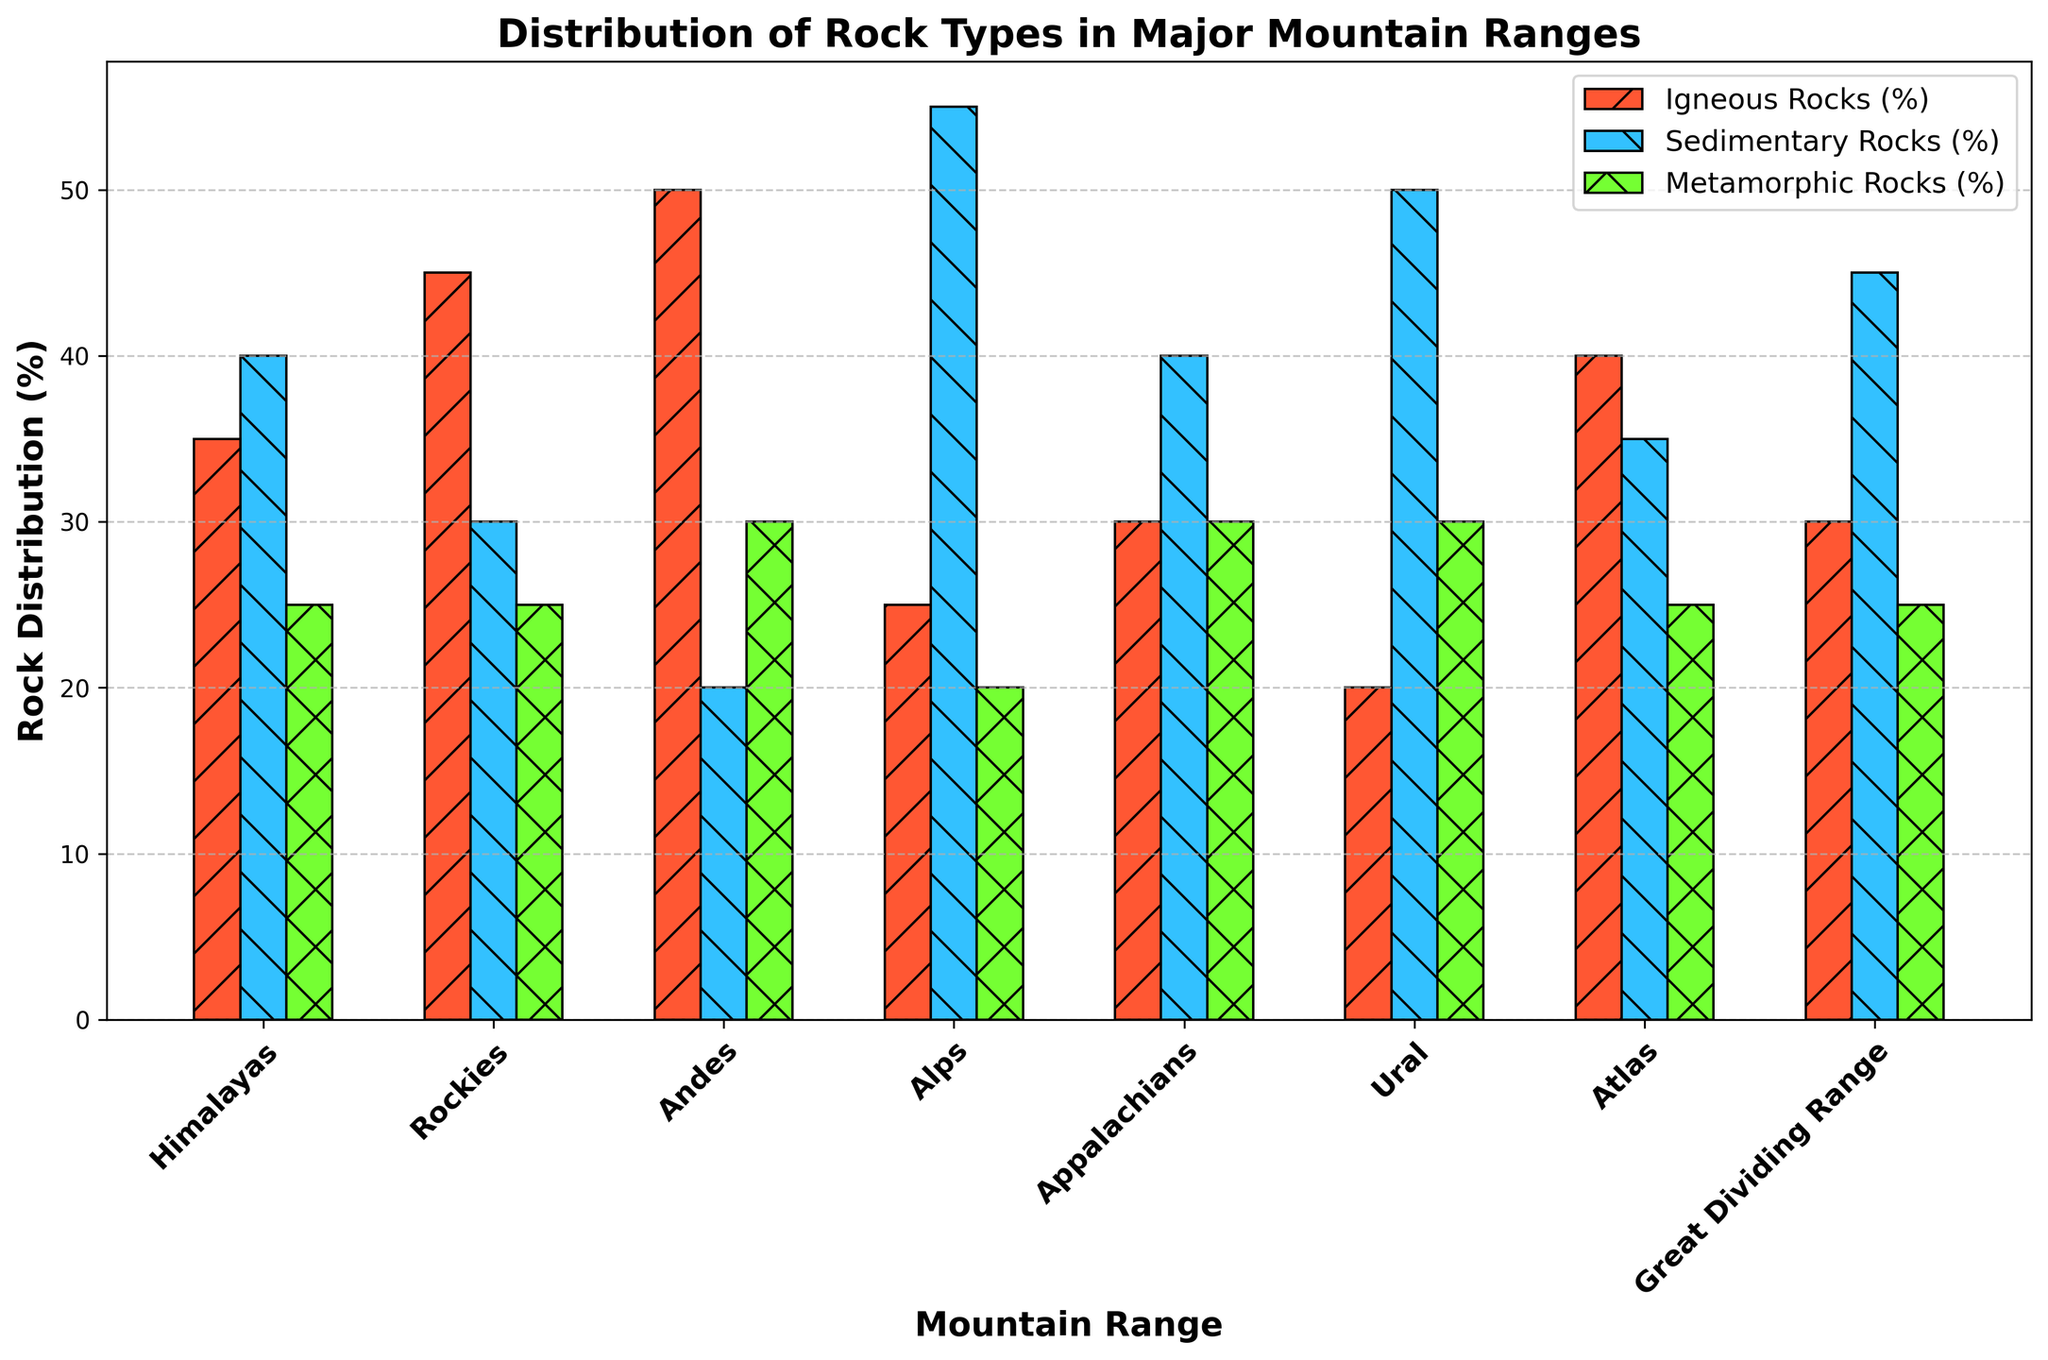Which mountain range has the highest proportion of igneous rocks? The figure displays the percentage of igneous rocks for each mountain range as bars. The Andes has the tallest bar for igneous rocks.
Answer: Andes Which mountain range has the lowest proportion of sedimentary rocks? The figure shows the percentage of sedimentary rocks for each mountain range. The Andes has the shortest bar for sedimentary rocks.
Answer: Andes What is the combined proportion of metamorphic rocks in the Alps and the Appalachians? To find the combined proportion, sum the values for metamorphic rocks in the Alps and the Appalachians: 20% + 30% = 50%.
Answer: 50% Which mountain range has an equal percentage distribution of igneous and metamorphic rocks? The figure reveals the percentages of each rock type across the mountain ranges. For the Appalachians, the bars for igneous and metamorphic rocks are equal at 30%.
Answer: Appalachians In which mountain range is the proportion of sedimentary rocks greater than igneous rocks by exactly 20%? Examine the figure for the mountain range where the bar for sedimentary rocks exceeds the bar for igneous rocks by 20%. In the Alps, the sedimentary rocks are 55%, and igneous rocks are 25%, so 55% - 25% = 30%. Instead, check the Ural Mountains: sedimentary = 50%, igneous = 20%, so 50% - 20% = 30%.
Answer: Ural Which mountain range has the largest difference in rock type proportions? The figure shows the differences in rock type percentages. The Alps have the largest differential: 55% sedimentary, 25% igneous (55% - 25% = 30%), and 20% metamorphic (55% - 20% = 35%).
Answer: Alps In which mountain ranges is the proportion of sedimentary rocks either maximum or second maximum? The figure depicts the percentages of sedimentary rocks, with the highest being in the Alps and the second highest in Ural.
Answer: Alps, Ural What is the average proportion of igneous rocks across all the mountain ranges? Identify the values for igneous rocks and calculate the average: (35 + 45 + 50 + 25 + 30 + 20 + 40 + 30) / 8 = 34.375%.
Answer: 34.375% Which mountain range has the highest total proportion of igneous and metamorphic rocks combined? To find this, sum the percentages for igneous and metamorphic rocks for each mountain range. The Andes (50% igneous + 30% metamorphic = 80%) have the highest combined proportion.
Answer: Andes 